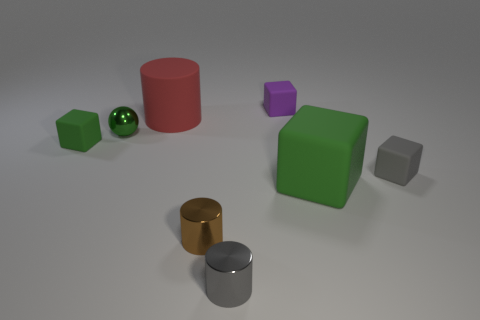Add 1 large red matte things. How many objects exist? 9 Subtract all balls. How many objects are left? 7 Subtract 0 cyan cylinders. How many objects are left? 8 Subtract all green matte things. Subtract all big green matte objects. How many objects are left? 5 Add 3 cylinders. How many cylinders are left? 6 Add 3 large brown matte cylinders. How many large brown matte cylinders exist? 3 